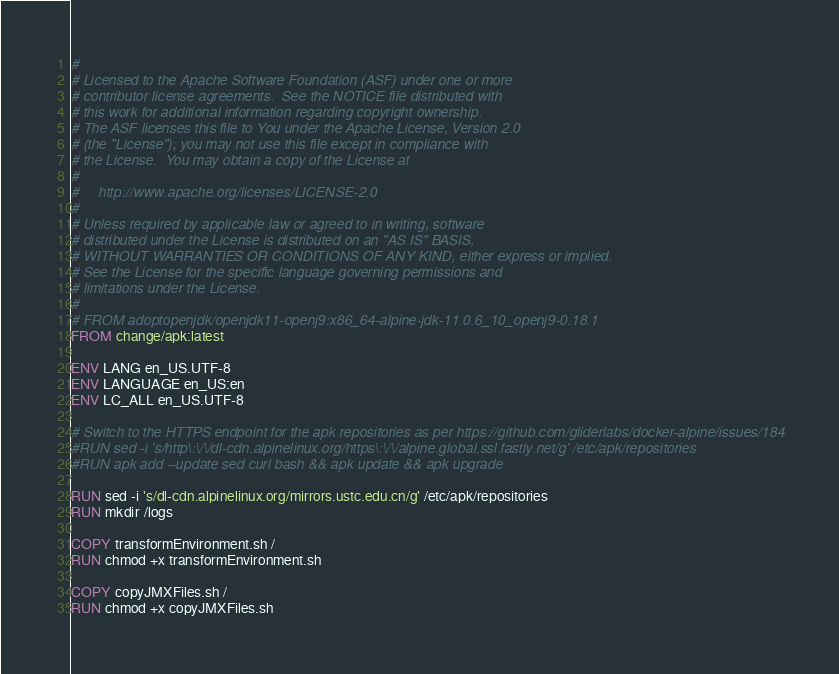Convert code to text. <code><loc_0><loc_0><loc_500><loc_500><_Dockerfile_>#
# Licensed to the Apache Software Foundation (ASF) under one or more
# contributor license agreements.  See the NOTICE file distributed with
# this work for additional information regarding copyright ownership.
# The ASF licenses this file to You under the Apache License, Version 2.0
# (the "License"); you may not use this file except in compliance with
# the License.  You may obtain a copy of the License at
#
#     http://www.apache.org/licenses/LICENSE-2.0
#
# Unless required by applicable law or agreed to in writing, software
# distributed under the License is distributed on an "AS IS" BASIS,
# WITHOUT WARRANTIES OR CONDITIONS OF ANY KIND, either express or implied.
# See the License for the specific language governing permissions and
# limitations under the License.
#
# FROM adoptopenjdk/openjdk11-openj9:x86_64-alpine-jdk-11.0.6_10_openj9-0.18.1
FROM change/apk:latest

ENV LANG en_US.UTF-8
ENV LANGUAGE en_US:en
ENV LC_ALL en_US.UTF-8

# Switch to the HTTPS endpoint for the apk repositories as per https://github.com/gliderlabs/docker-alpine/issues/184
#RUN sed -i 's/http\:\/\/dl-cdn.alpinelinux.org/https\:\/\/alpine.global.ssl.fastly.net/g' /etc/apk/repositories
#RUN apk add --update sed curl bash && apk update && apk upgrade

RUN sed -i 's/dl-cdn.alpinelinux.org/mirrors.ustc.edu.cn/g' /etc/apk/repositories
RUN mkdir /logs

COPY transformEnvironment.sh /
RUN chmod +x transformEnvironment.sh

COPY copyJMXFiles.sh /
RUN chmod +x copyJMXFiles.sh
</code> 